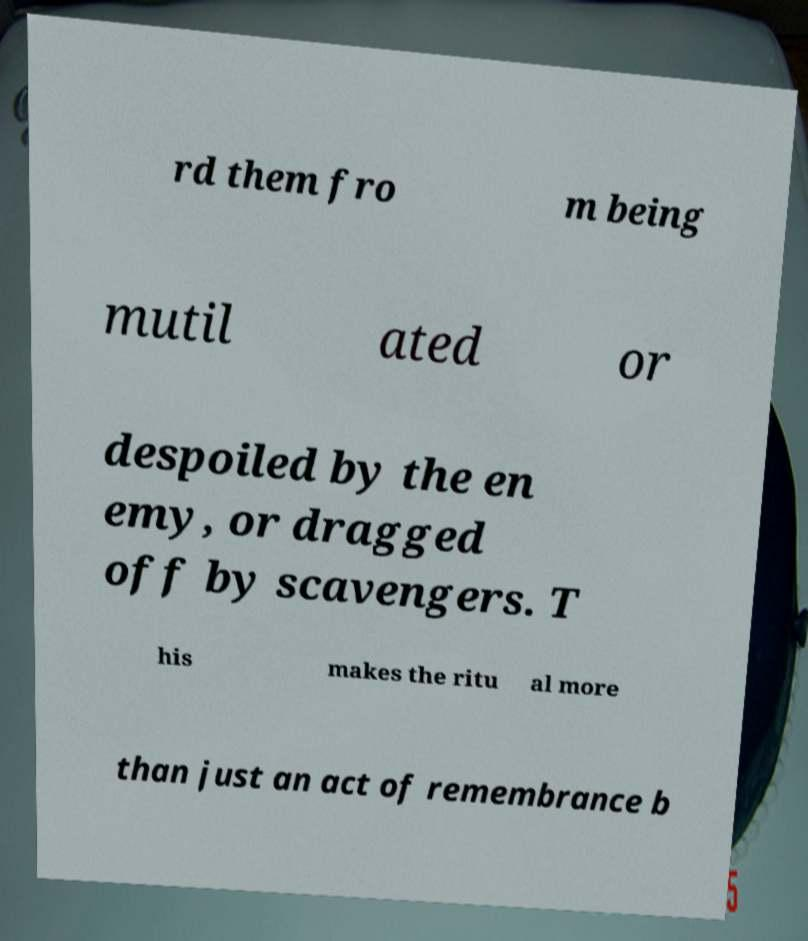There's text embedded in this image that I need extracted. Can you transcribe it verbatim? rd them fro m being mutil ated or despoiled by the en emy, or dragged off by scavengers. T his makes the ritu al more than just an act of remembrance b 